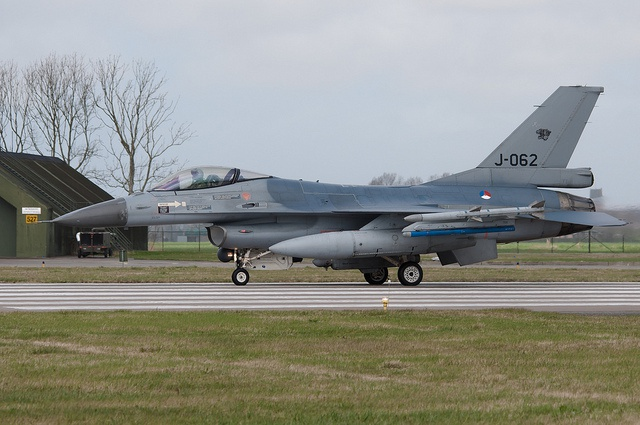Describe the objects in this image and their specific colors. I can see airplane in lightgray, gray, black, and darkgray tones, truck in lightgray, black, and gray tones, and people in lightgray, darkgray, gray, and black tones in this image. 